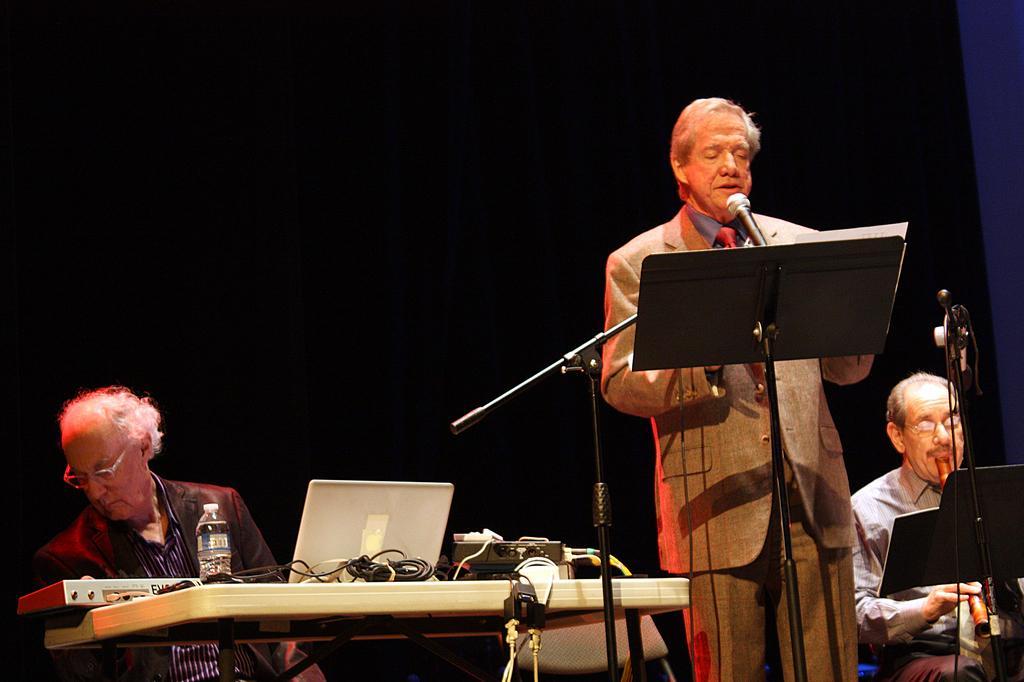Describe this image in one or two sentences. This is the man standing. He wore a suit, shirt, tie and trouser. This looks like a music stand. There is a mike attached to the mike stand. I can see two men sitting. This looks like a table with a laptop, water bottle, piano, cable and few other things on it. This man is playing the musical instrument. The background looks dark. 